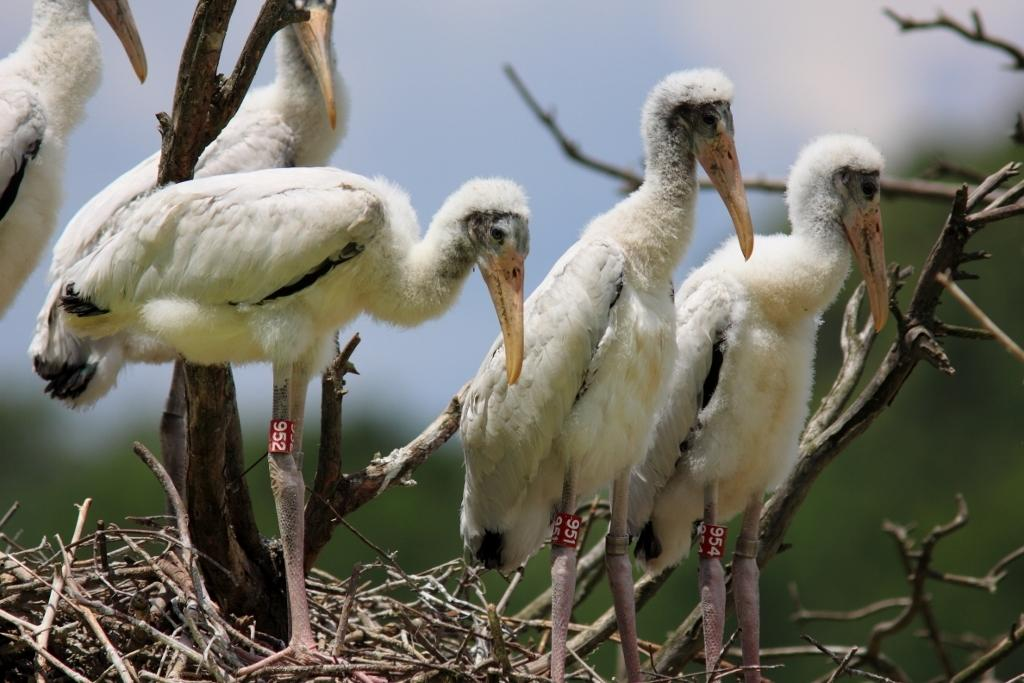What type of animals can be seen in the image? There are birds in the image. What can be seen on the legs of the birds? The birds have stickers on their legs. What is visible in the image besides the birds? There are branches visible in the image. How would you describe the background of the image? The background of the image is blurred. What book is the bird reading in the image? There is no book present in the image, and birds do not read. 